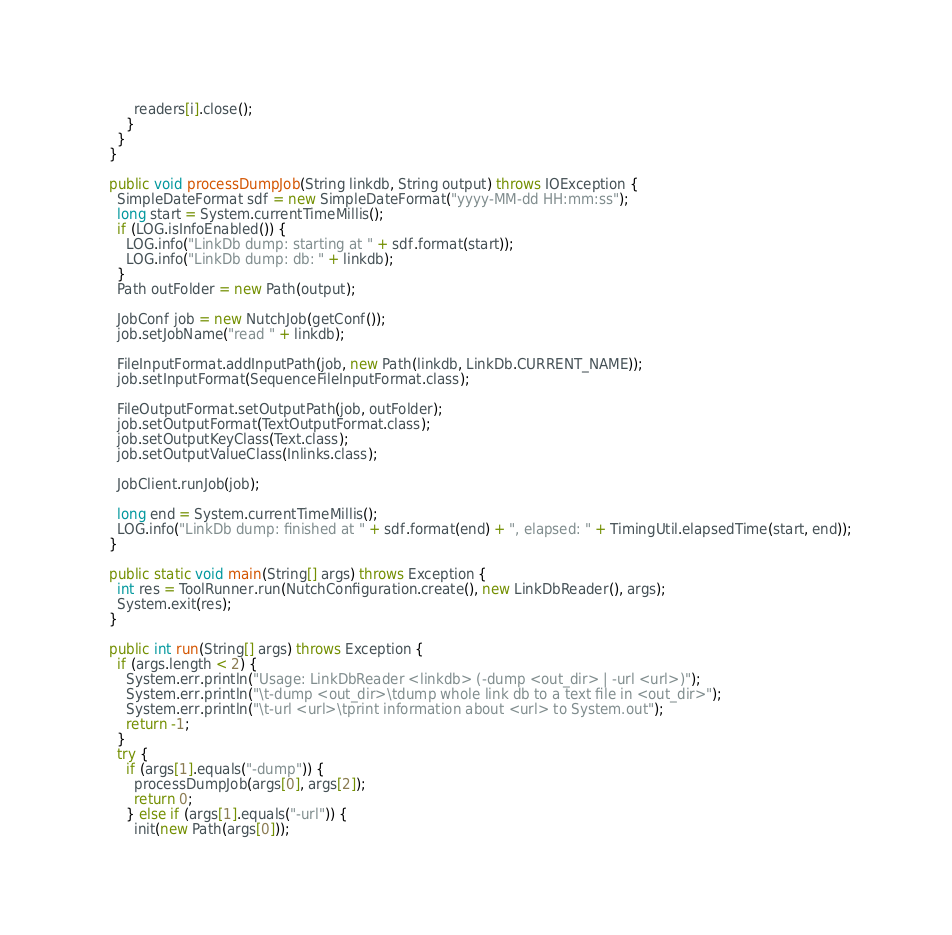Convert code to text. <code><loc_0><loc_0><loc_500><loc_500><_Java_>        readers[i].close();
      }
    }
  }
  
  public void processDumpJob(String linkdb, String output) throws IOException {
    SimpleDateFormat sdf = new SimpleDateFormat("yyyy-MM-dd HH:mm:ss");
    long start = System.currentTimeMillis();
    if (LOG.isInfoEnabled()) {
      LOG.info("LinkDb dump: starting at " + sdf.format(start));
      LOG.info("LinkDb dump: db: " + linkdb);
    }
    Path outFolder = new Path(output);

    JobConf job = new NutchJob(getConf());
    job.setJobName("read " + linkdb);

    FileInputFormat.addInputPath(job, new Path(linkdb, LinkDb.CURRENT_NAME));
    job.setInputFormat(SequenceFileInputFormat.class);

    FileOutputFormat.setOutputPath(job, outFolder);
    job.setOutputFormat(TextOutputFormat.class);
    job.setOutputKeyClass(Text.class);
    job.setOutputValueClass(Inlinks.class);

    JobClient.runJob(job);

    long end = System.currentTimeMillis();
    LOG.info("LinkDb dump: finished at " + sdf.format(end) + ", elapsed: " + TimingUtil.elapsedTime(start, end));
  }
  
  public static void main(String[] args) throws Exception {
    int res = ToolRunner.run(NutchConfiguration.create(), new LinkDbReader(), args);
    System.exit(res);
  }
  
  public int run(String[] args) throws Exception {
    if (args.length < 2) {
      System.err.println("Usage: LinkDbReader <linkdb> (-dump <out_dir> | -url <url>)");
      System.err.println("\t-dump <out_dir>\tdump whole link db to a text file in <out_dir>");
      System.err.println("\t-url <url>\tprint information about <url> to System.out");
      return -1;
    }
    try {
      if (args[1].equals("-dump")) {
        processDumpJob(args[0], args[2]);
        return 0;
      } else if (args[1].equals("-url")) {
        init(new Path(args[0]));</code> 